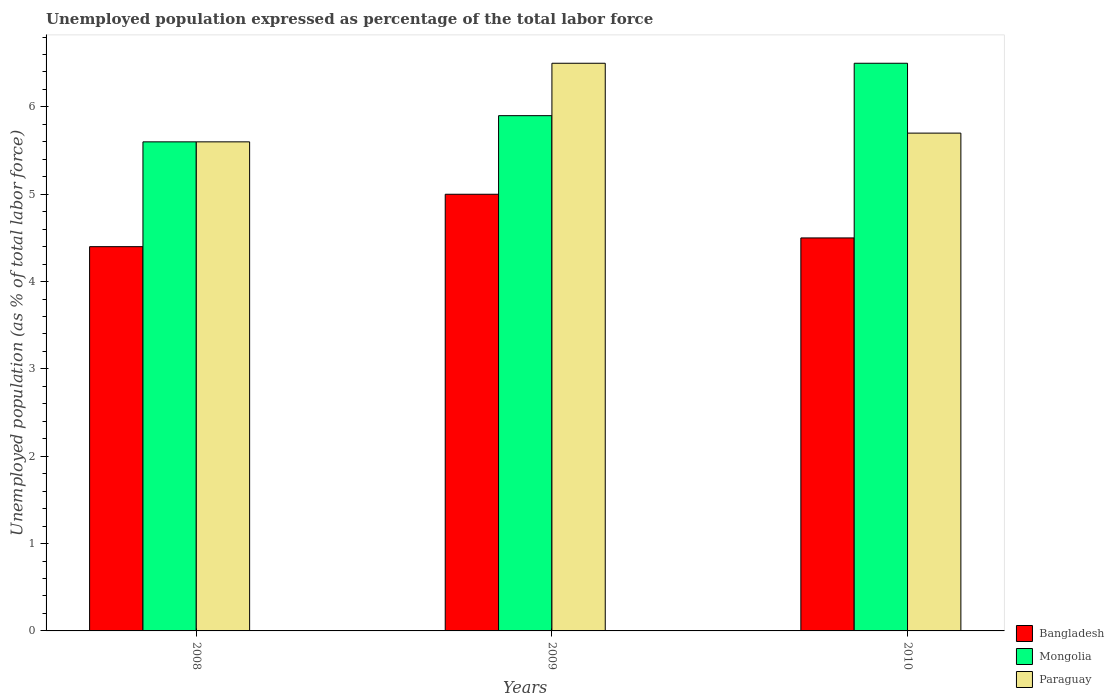How many groups of bars are there?
Provide a short and direct response. 3. Are the number of bars per tick equal to the number of legend labels?
Your answer should be very brief. Yes. Are the number of bars on each tick of the X-axis equal?
Provide a short and direct response. Yes. How many bars are there on the 3rd tick from the right?
Offer a terse response. 3. Across all years, what is the minimum unemployment in in Paraguay?
Your answer should be compact. 5.6. In which year was the unemployment in in Bangladesh minimum?
Ensure brevity in your answer.  2008. What is the total unemployment in in Bangladesh in the graph?
Your answer should be compact. 13.9. What is the difference between the unemployment in in Bangladesh in 2008 and that in 2010?
Your answer should be very brief. -0.1. What is the difference between the unemployment in in Paraguay in 2008 and the unemployment in in Bangladesh in 2009?
Offer a very short reply. 0.6. What is the average unemployment in in Bangladesh per year?
Keep it short and to the point. 4.63. In the year 2008, what is the difference between the unemployment in in Paraguay and unemployment in in Bangladesh?
Ensure brevity in your answer.  1.2. What is the ratio of the unemployment in in Paraguay in 2009 to that in 2010?
Offer a very short reply. 1.14. What is the difference between the highest and the second highest unemployment in in Mongolia?
Your response must be concise. 0.6. What is the difference between the highest and the lowest unemployment in in Paraguay?
Your answer should be compact. 0.9. What does the 1st bar from the left in 2009 represents?
Ensure brevity in your answer.  Bangladesh. What does the 2nd bar from the right in 2010 represents?
Make the answer very short. Mongolia. Is it the case that in every year, the sum of the unemployment in in Bangladesh and unemployment in in Mongolia is greater than the unemployment in in Paraguay?
Make the answer very short. Yes. How many bars are there?
Provide a succinct answer. 9. How many years are there in the graph?
Make the answer very short. 3. Are the values on the major ticks of Y-axis written in scientific E-notation?
Offer a very short reply. No. Does the graph contain grids?
Offer a terse response. No. How are the legend labels stacked?
Ensure brevity in your answer.  Vertical. What is the title of the graph?
Your response must be concise. Unemployed population expressed as percentage of the total labor force. What is the label or title of the Y-axis?
Your answer should be very brief. Unemployed population (as % of total labor force). What is the Unemployed population (as % of total labor force) in Bangladesh in 2008?
Your response must be concise. 4.4. What is the Unemployed population (as % of total labor force) in Mongolia in 2008?
Your answer should be compact. 5.6. What is the Unemployed population (as % of total labor force) in Paraguay in 2008?
Make the answer very short. 5.6. What is the Unemployed population (as % of total labor force) in Mongolia in 2009?
Make the answer very short. 5.9. What is the Unemployed population (as % of total labor force) in Paraguay in 2009?
Offer a very short reply. 6.5. What is the Unemployed population (as % of total labor force) in Bangladesh in 2010?
Provide a succinct answer. 4.5. What is the Unemployed population (as % of total labor force) of Mongolia in 2010?
Your response must be concise. 6.5. What is the Unemployed population (as % of total labor force) in Paraguay in 2010?
Your response must be concise. 5.7. Across all years, what is the maximum Unemployed population (as % of total labor force) in Bangladesh?
Your answer should be compact. 5. Across all years, what is the maximum Unemployed population (as % of total labor force) in Mongolia?
Provide a short and direct response. 6.5. Across all years, what is the maximum Unemployed population (as % of total labor force) of Paraguay?
Give a very brief answer. 6.5. Across all years, what is the minimum Unemployed population (as % of total labor force) of Bangladesh?
Offer a terse response. 4.4. Across all years, what is the minimum Unemployed population (as % of total labor force) in Mongolia?
Your answer should be very brief. 5.6. Across all years, what is the minimum Unemployed population (as % of total labor force) of Paraguay?
Your answer should be compact. 5.6. What is the total Unemployed population (as % of total labor force) in Bangladesh in the graph?
Your response must be concise. 13.9. What is the total Unemployed population (as % of total labor force) of Mongolia in the graph?
Make the answer very short. 18. What is the total Unemployed population (as % of total labor force) of Paraguay in the graph?
Make the answer very short. 17.8. What is the difference between the Unemployed population (as % of total labor force) of Bangladesh in 2008 and that in 2009?
Offer a terse response. -0.6. What is the difference between the Unemployed population (as % of total labor force) of Mongolia in 2008 and that in 2009?
Make the answer very short. -0.3. What is the difference between the Unemployed population (as % of total labor force) in Paraguay in 2008 and that in 2009?
Your answer should be very brief. -0.9. What is the difference between the Unemployed population (as % of total labor force) of Mongolia in 2008 and that in 2010?
Offer a very short reply. -0.9. What is the difference between the Unemployed population (as % of total labor force) of Mongolia in 2009 and that in 2010?
Offer a very short reply. -0.6. What is the difference between the Unemployed population (as % of total labor force) in Paraguay in 2009 and that in 2010?
Give a very brief answer. 0.8. What is the difference between the Unemployed population (as % of total labor force) of Bangladesh in 2008 and the Unemployed population (as % of total labor force) of Mongolia in 2009?
Your answer should be compact. -1.5. What is the difference between the Unemployed population (as % of total labor force) in Bangladesh in 2008 and the Unemployed population (as % of total labor force) in Paraguay in 2009?
Your answer should be very brief. -2.1. What is the difference between the Unemployed population (as % of total labor force) of Mongolia in 2008 and the Unemployed population (as % of total labor force) of Paraguay in 2009?
Ensure brevity in your answer.  -0.9. What is the difference between the Unemployed population (as % of total labor force) of Bangladesh in 2008 and the Unemployed population (as % of total labor force) of Mongolia in 2010?
Your answer should be compact. -2.1. What is the difference between the Unemployed population (as % of total labor force) in Bangladesh in 2008 and the Unemployed population (as % of total labor force) in Paraguay in 2010?
Offer a very short reply. -1.3. What is the difference between the Unemployed population (as % of total labor force) in Bangladesh in 2009 and the Unemployed population (as % of total labor force) in Mongolia in 2010?
Your answer should be very brief. -1.5. What is the difference between the Unemployed population (as % of total labor force) in Bangladesh in 2009 and the Unemployed population (as % of total labor force) in Paraguay in 2010?
Keep it short and to the point. -0.7. What is the average Unemployed population (as % of total labor force) of Bangladesh per year?
Provide a short and direct response. 4.63. What is the average Unemployed population (as % of total labor force) of Mongolia per year?
Offer a very short reply. 6. What is the average Unemployed population (as % of total labor force) of Paraguay per year?
Ensure brevity in your answer.  5.93. In the year 2009, what is the difference between the Unemployed population (as % of total labor force) of Bangladesh and Unemployed population (as % of total labor force) of Paraguay?
Provide a short and direct response. -1.5. In the year 2010, what is the difference between the Unemployed population (as % of total labor force) in Bangladesh and Unemployed population (as % of total labor force) in Mongolia?
Your answer should be very brief. -2. In the year 2010, what is the difference between the Unemployed population (as % of total labor force) in Mongolia and Unemployed population (as % of total labor force) in Paraguay?
Make the answer very short. 0.8. What is the ratio of the Unemployed population (as % of total labor force) in Mongolia in 2008 to that in 2009?
Your answer should be compact. 0.95. What is the ratio of the Unemployed population (as % of total labor force) in Paraguay in 2008 to that in 2009?
Your response must be concise. 0.86. What is the ratio of the Unemployed population (as % of total labor force) in Bangladesh in 2008 to that in 2010?
Your answer should be very brief. 0.98. What is the ratio of the Unemployed population (as % of total labor force) in Mongolia in 2008 to that in 2010?
Provide a succinct answer. 0.86. What is the ratio of the Unemployed population (as % of total labor force) in Paraguay in 2008 to that in 2010?
Your response must be concise. 0.98. What is the ratio of the Unemployed population (as % of total labor force) of Mongolia in 2009 to that in 2010?
Provide a succinct answer. 0.91. What is the ratio of the Unemployed population (as % of total labor force) of Paraguay in 2009 to that in 2010?
Your answer should be compact. 1.14. What is the difference between the highest and the second highest Unemployed population (as % of total labor force) of Bangladesh?
Your answer should be very brief. 0.5. What is the difference between the highest and the second highest Unemployed population (as % of total labor force) in Mongolia?
Your answer should be compact. 0.6. What is the difference between the highest and the lowest Unemployed population (as % of total labor force) of Mongolia?
Give a very brief answer. 0.9. 